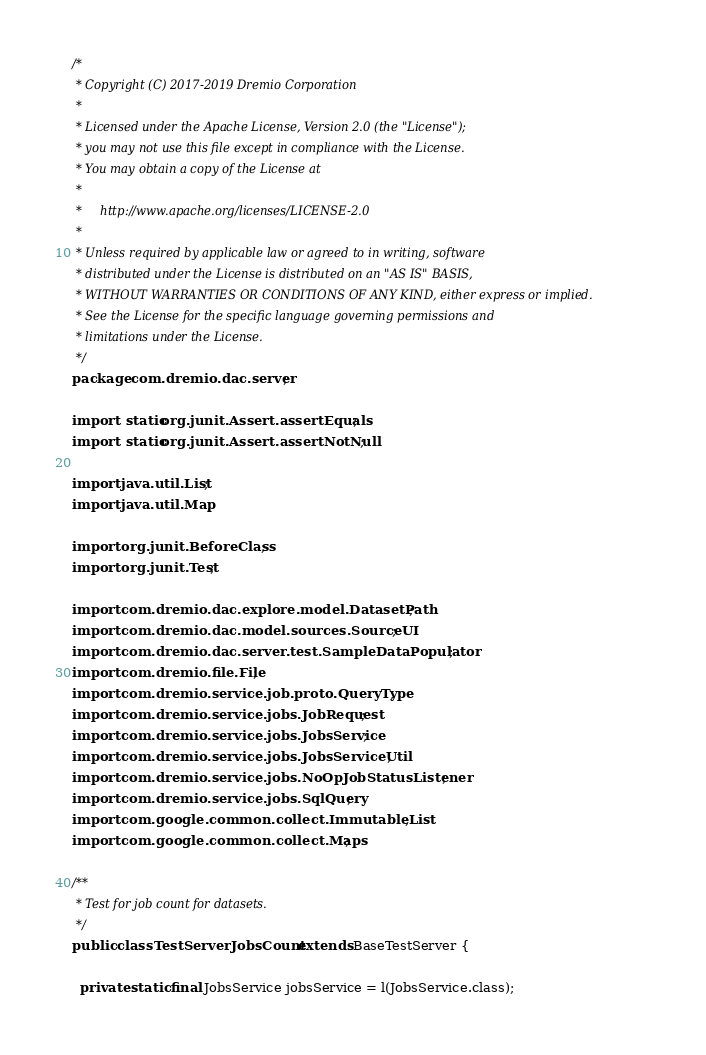Convert code to text. <code><loc_0><loc_0><loc_500><loc_500><_Java_>/*
 * Copyright (C) 2017-2019 Dremio Corporation
 *
 * Licensed under the Apache License, Version 2.0 (the "License");
 * you may not use this file except in compliance with the License.
 * You may obtain a copy of the License at
 *
 *     http://www.apache.org/licenses/LICENSE-2.0
 *
 * Unless required by applicable law or agreed to in writing, software
 * distributed under the License is distributed on an "AS IS" BASIS,
 * WITHOUT WARRANTIES OR CONDITIONS OF ANY KIND, either express or implied.
 * See the License for the specific language governing permissions and
 * limitations under the License.
 */
package com.dremio.dac.server;

import static org.junit.Assert.assertEquals;
import static org.junit.Assert.assertNotNull;

import java.util.List;
import java.util.Map;

import org.junit.BeforeClass;
import org.junit.Test;

import com.dremio.dac.explore.model.DatasetPath;
import com.dremio.dac.model.sources.SourceUI;
import com.dremio.dac.server.test.SampleDataPopulator;
import com.dremio.file.File;
import com.dremio.service.job.proto.QueryType;
import com.dremio.service.jobs.JobRequest;
import com.dremio.service.jobs.JobsService;
import com.dremio.service.jobs.JobsServiceUtil;
import com.dremio.service.jobs.NoOpJobStatusListener;
import com.dremio.service.jobs.SqlQuery;
import com.google.common.collect.ImmutableList;
import com.google.common.collect.Maps;

/**
 * Test for job count for datasets.
 */
public class TestServerJobsCount extends BaseTestServer {

  private static final JobsService jobsService = l(JobsService.class);</code> 